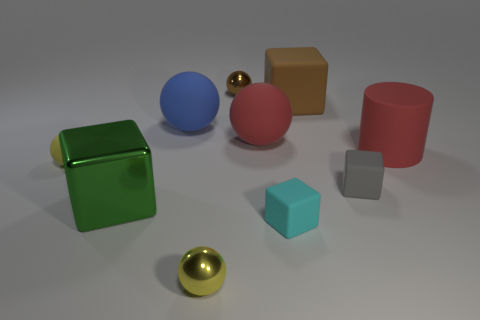How big is the object behind the brown object on the right side of the small shiny thing that is behind the big green metallic block?
Make the answer very short. Small. The gray object is what size?
Give a very brief answer. Small. Is there anything else that is made of the same material as the gray thing?
Your response must be concise. Yes. There is a tiny yellow object that is on the right side of the big cube that is left of the brown metal thing; are there any brown spheres that are to the left of it?
Provide a succinct answer. No. What number of tiny objects are either red matte balls or gray rubber things?
Your response must be concise. 1. Is there anything else of the same color as the large rubber cube?
Your answer should be compact. Yes. Do the yellow sphere that is to the right of the yellow matte object and the big green metallic object have the same size?
Offer a terse response. No. There is a ball that is behind the brown thing that is in front of the shiny sphere behind the small cyan matte cube; what color is it?
Provide a succinct answer. Brown. What is the color of the shiny cube?
Offer a very short reply. Green. Is the large shiny cube the same color as the cylinder?
Offer a terse response. No. 